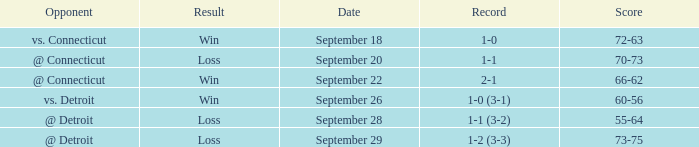What is the date with score of 66-62? September 22. 